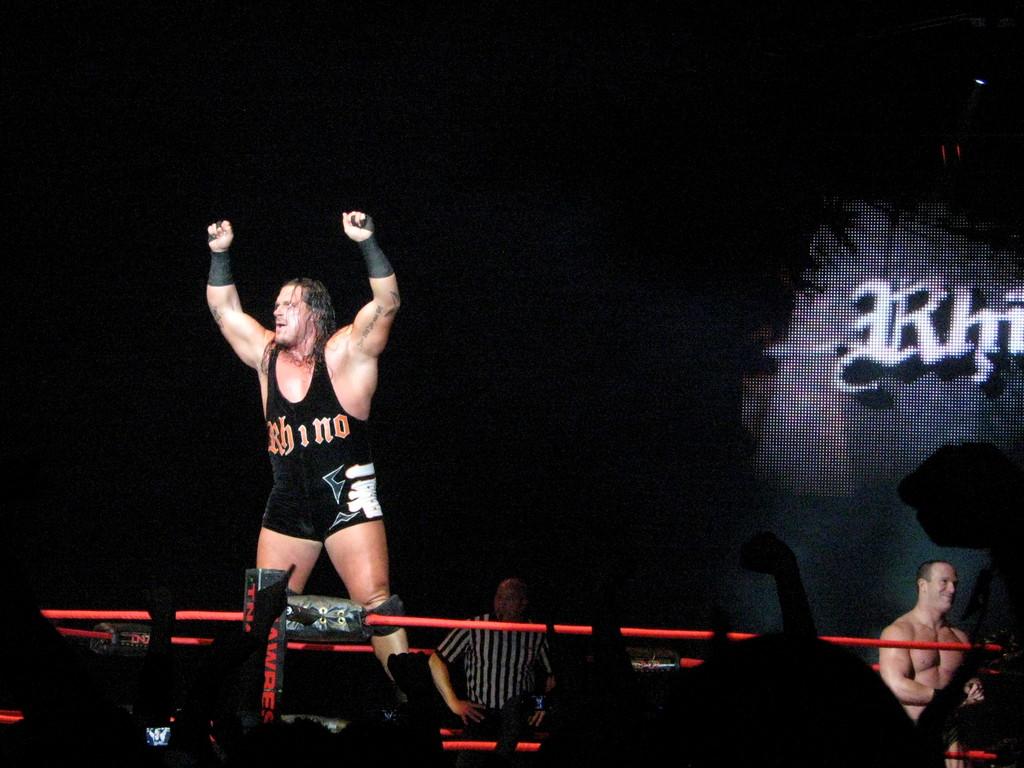What is the wrestler's name on the front of his outfit?
Ensure brevity in your answer.  Rhino. 